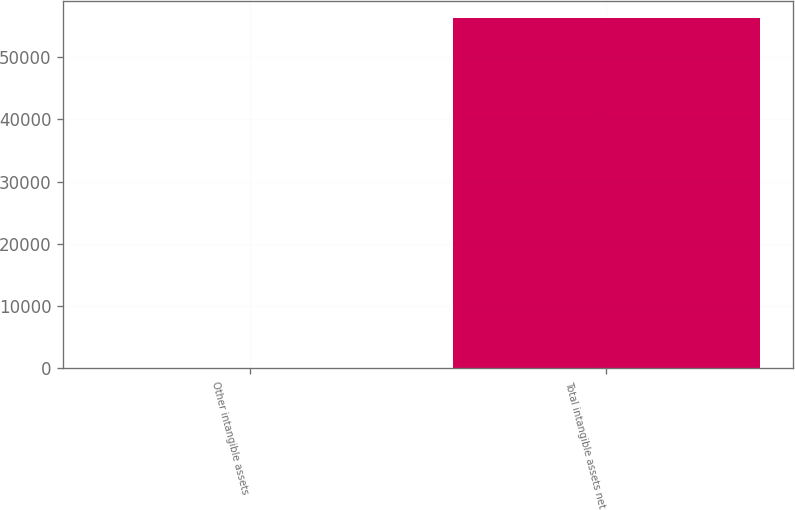<chart> <loc_0><loc_0><loc_500><loc_500><bar_chart><fcel>Other intangible assets<fcel>Total intangible assets net<nl><fcel>13<fcel>56230<nl></chart> 